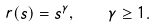Convert formula to latex. <formula><loc_0><loc_0><loc_500><loc_500>r ( s ) = s ^ { \gamma } , \quad \gamma \geq 1 .</formula> 